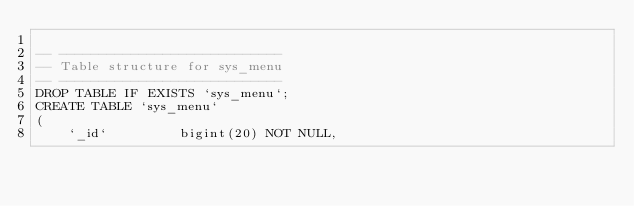Convert code to text. <code><loc_0><loc_0><loc_500><loc_500><_SQL_>
-- ----------------------------
-- Table structure for sys_menu
-- ----------------------------
DROP TABLE IF EXISTS `sys_menu`;
CREATE TABLE `sys_menu`
(
    `_id`         bigint(20) NOT NULL,</code> 